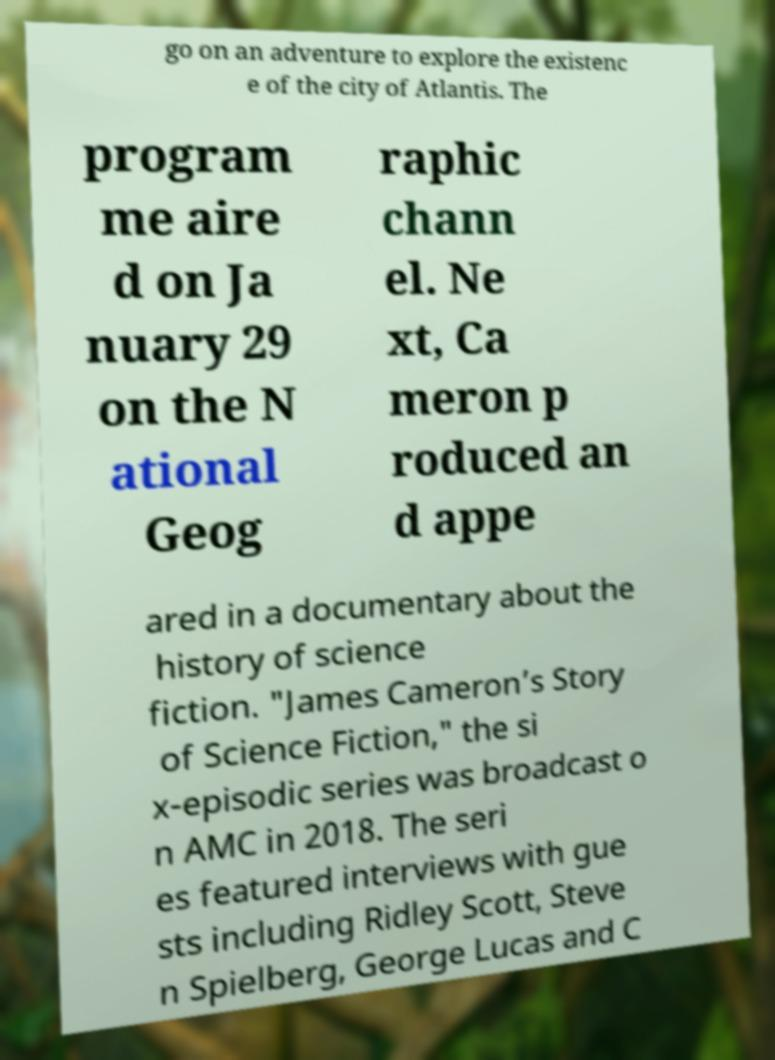Can you accurately transcribe the text from the provided image for me? go on an adventure to explore the existenc e of the city of Atlantis. The program me aire d on Ja nuary 29 on the N ational Geog raphic chann el. Ne xt, Ca meron p roduced an d appe ared in a documentary about the history of science fiction. "James Cameron’s Story of Science Fiction," the si x-episodic series was broadcast o n AMC in 2018. The seri es featured interviews with gue sts including Ridley Scott, Steve n Spielberg, George Lucas and C 